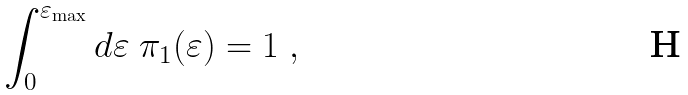<formula> <loc_0><loc_0><loc_500><loc_500>\int _ { 0 } ^ { \varepsilon _ { \max } } d \varepsilon \ \pi _ { 1 } ( \varepsilon ) = 1 \ ,</formula> 